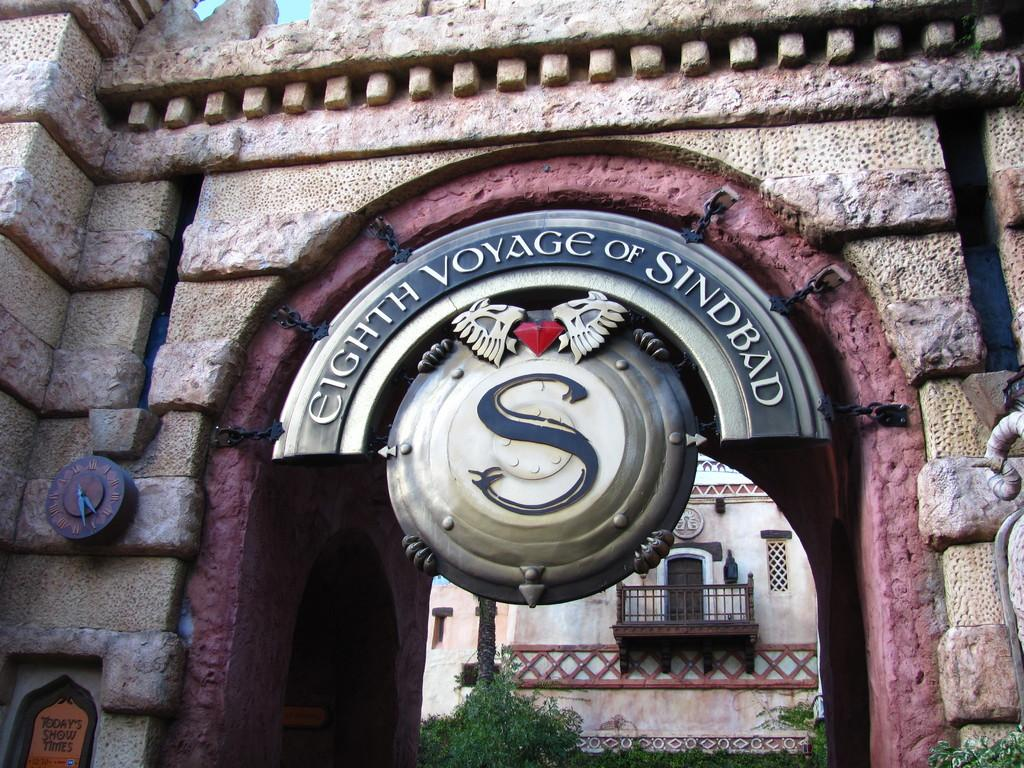What is located in the foreground of the picture? There is a wall and a board in the foreground of the picture. What can be seen in the background of the picture? There are trees and a building in the background of the picture. What type of field is visible in the background of the image? There is no field present in the image; it features trees and a building in the background. What type of exchange is taking place between the wall and the board in the foreground of the image? There is no exchange taking place between the wall and the board in the image; they are simply located next to each other. 